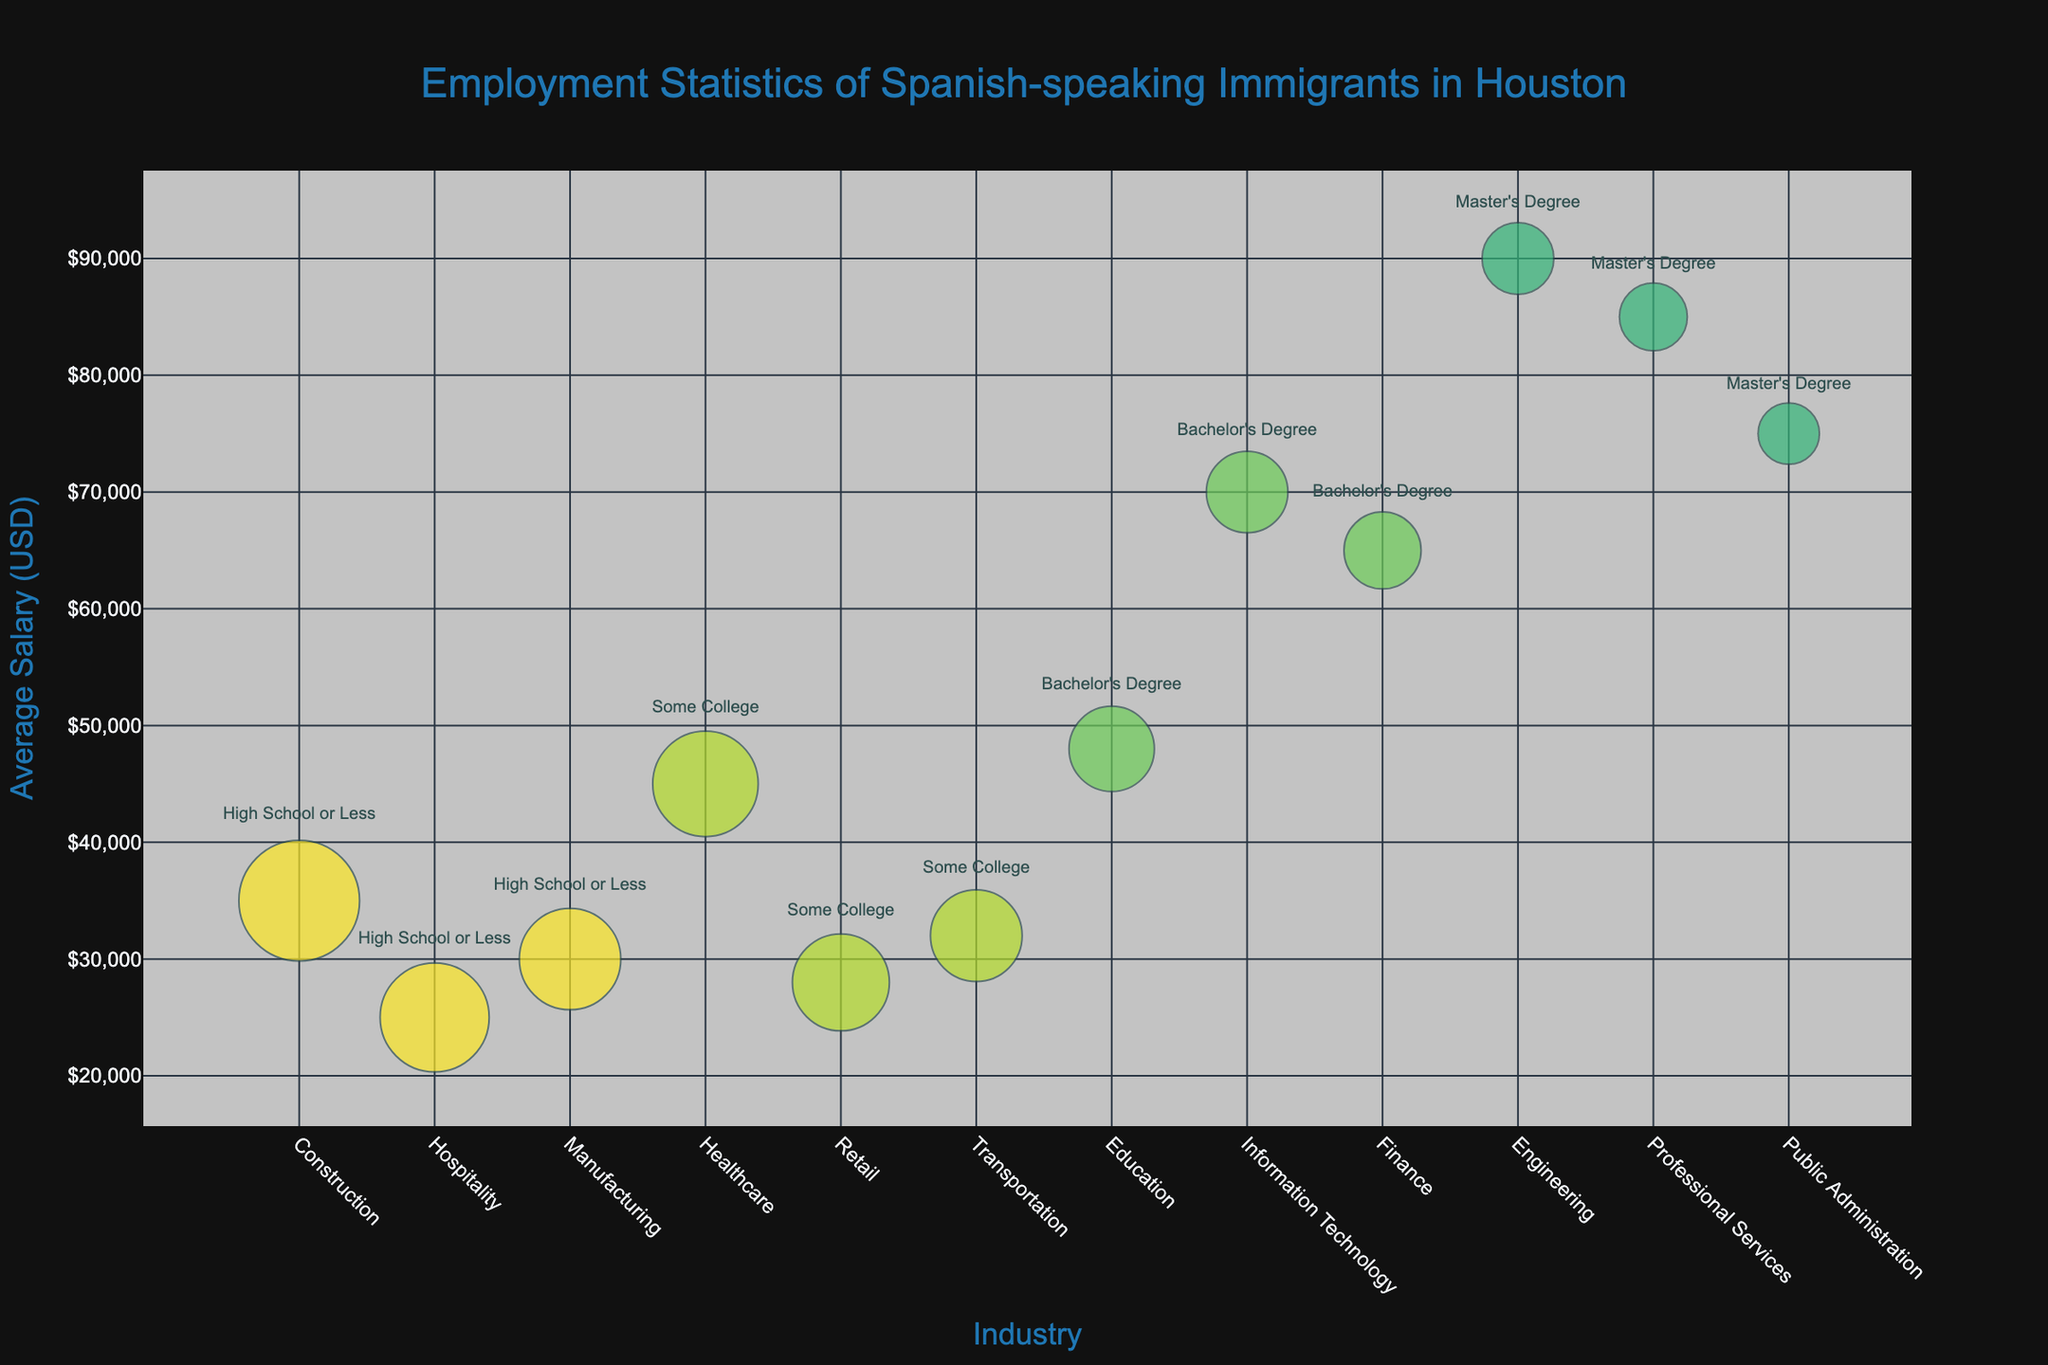How many industries are shown in the plot? Count the number of unique industries listed on the x-axis.
Answer: 12 What is the average salary in the Construction industry for those with High School or Less education? Identify the Construction industry bubble on the x-axis and look at the y-axis value for the average salary of that bubble.
Answer: 35,000 Which industry has the highest average salary for immigrants with a Master's Degree? Look for the largest bubble within the Master's Degree color category and check its position on the y-axis.
Answer: Engineering How many industries offer an average salary above 50,000 USD? Count the number of bubbles positioned above the 50,000 USD mark on the y-axis.
Answer: 5 What is the relationship between the industry with the highest number of employees and its average salary? Identify the largest bubble (size wise) and note its industry and y-axis value for salary.
Answer: Construction; 35,000 USD How does the number of employees vary between the Hospitality industry and the Finance industry? Compare the size of the bubbles corresponding to Hospitality and Finance industries.
Answer: Hospitality has more employees What education level is most common among Spanish-speaking immigrants employed in the Healthcare industry? Look at the bubble for Healthcare and note the text or color indicating the education level.
Answer: Some College Which industry has the smallest bubble and what does its size represent? Identify the smallest bubble and check its industry; the size represents the number of employees.
Answer: Public Administration; 800 employees What is the salary difference between the highest-paid and lowest-paid industries for those with Bachelor's Degrees? Identify the bubbles for the highest and lowest average salaries within Bachelor's Degree and compute the difference.
Answer: 70,000 - 48,000 = 22,000 USD 